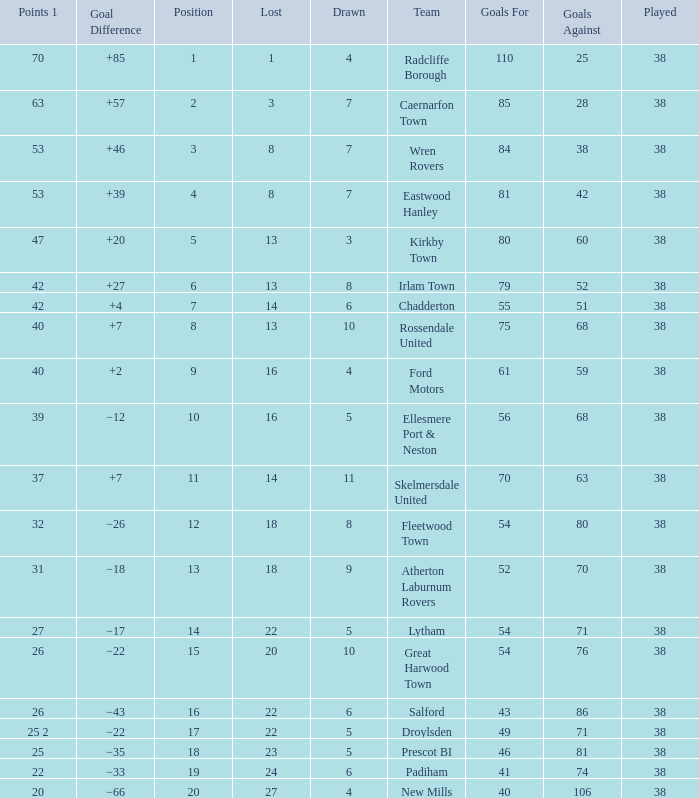Which Played has a Drawn of 4, and a Position of 9, and Goals Against larger than 59? None. 